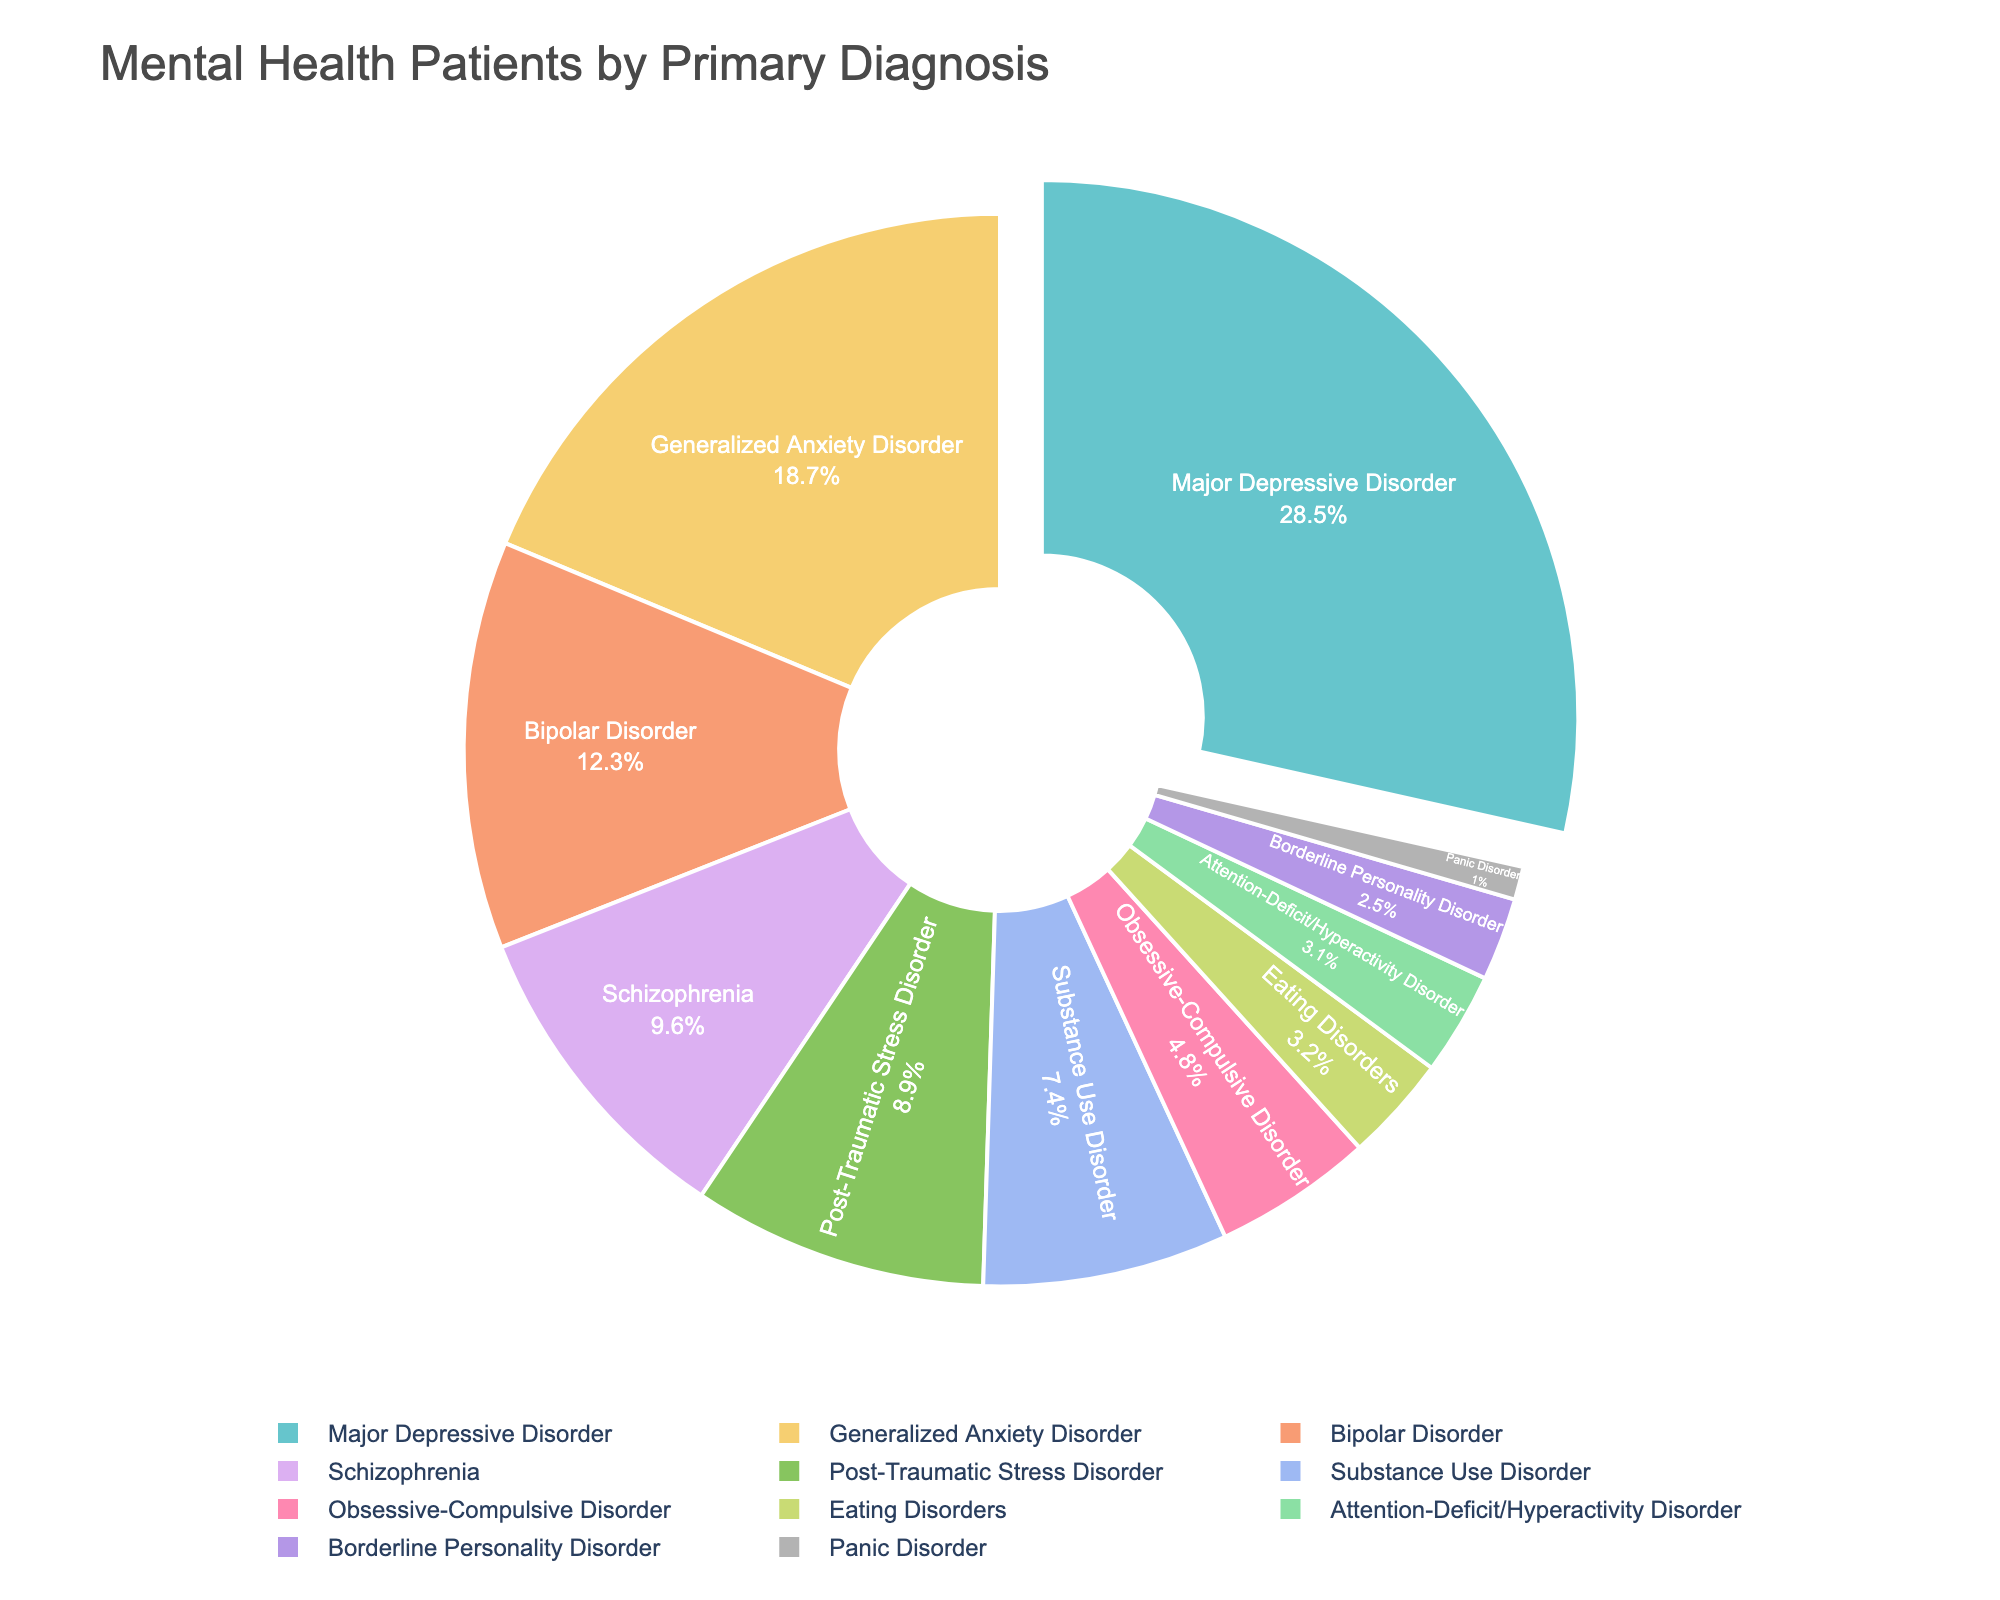What is the most common primary diagnosis among mental health patients in community health centers? Major Depressive Disorder has the largest section in the pie chart, indicating it is the most common diagnosis.
Answer: Major Depressive Disorder Which primary diagnosis has the smallest percentage? Panic Disorder is represented by the smallest section of the pie chart, indicating it has the smallest percentage.
Answer: Panic Disorder How much larger is the percentage of patients with Major Depressive Disorder compared to those with Generalized Anxiety Disorder? Subtract the percentage of Generalized Anxiety Disorder (18.7%) from Major Depressive Disorder (28.5%): 28.5% - 18.7% = 9.8%.
Answer: 9.8% What's the combined percentage of patients diagnosed with Schizophrenia and Post-Traumatic Stress Disorder? Add the percentages of Schizophrenia (9.6%) and Post-Traumatic Stress Disorder (8.9%): 9.6% + 8.9% = 18.5%.
Answer: 18.5% Which has a higher percentage: Substance Use Disorder or Obsessive-Compulsive Disorder? The slice for Substance Use Disorder is larger than that for Obsessive-Compulsive Disorder.
Answer: Substance Use Disorder If you combine the percentages of all personality and anxiety-related disorders (Generalized Anxiety Disorder, Panic Disorder, Obsessive-Compulsive Disorder, and Borderline Personality Disorder), what is the total percentage? Add the percentages: Generalized Anxiety Disorder (18.7%) + Panic Disorder (1.0%) + Obsessive-Compulsive Disorder (4.8%) + Borderline Personality Disorder (2.5%) = 27.0%.
Answer: 27.0% What is the difference in percentage between Bipolar Disorder and Eating Disorders? Subtract the percentage of Eating Disorders (3.2%) from Bipolar Disorder (12.3%): 12.3% - 3.2% = 9.1%.
Answer: 9.1% Are there more patients with Attention-Deficit/Hyperactivity Disorder or with Borderline Personality Disorder? The pie chart shows a larger slice for Attention-Deficit/Hyperactivity Disorder than for Borderline Personality Disorder.
Answer: Attention-Deficit/Hyperactivity Disorder Which sections of the pie chart are highlighted (pulled out)? The slice representing Major Depressive Disorder is pulled out, indicating it has the most significant percentage.
Answer: Major Depressive Disorder What is the sum of the percentages for Bipolar Disorder, Schizophrenia, and PTSD (Post-Traumatic Stress Disorder)? Add the percentages: Bipolar Disorder (12.3%) + Schizophrenia (9.6%) + PTSD (8.9%) = 30.8%.
Answer: 30.8% 